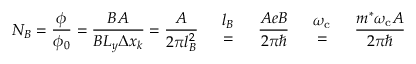<formula> <loc_0><loc_0><loc_500><loc_500>N _ { B } = { \frac { \phi } { \phi _ { 0 } } } = { \frac { B A } { B L _ { y } \Delta x _ { k } } } = { \frac { A } { 2 \pi l _ { B } ^ { 2 } } } { \begin{array} { l c r } & { l _ { B } } & \\ & { = } & \end{array} } { \frac { A e B } { 2 \pi } } { \begin{array} { l c r } & { \omega _ { c } } & \\ & { = } & \end{array} } { \frac { m ^ { * } \omega _ { c } A } { 2 \pi } }</formula> 